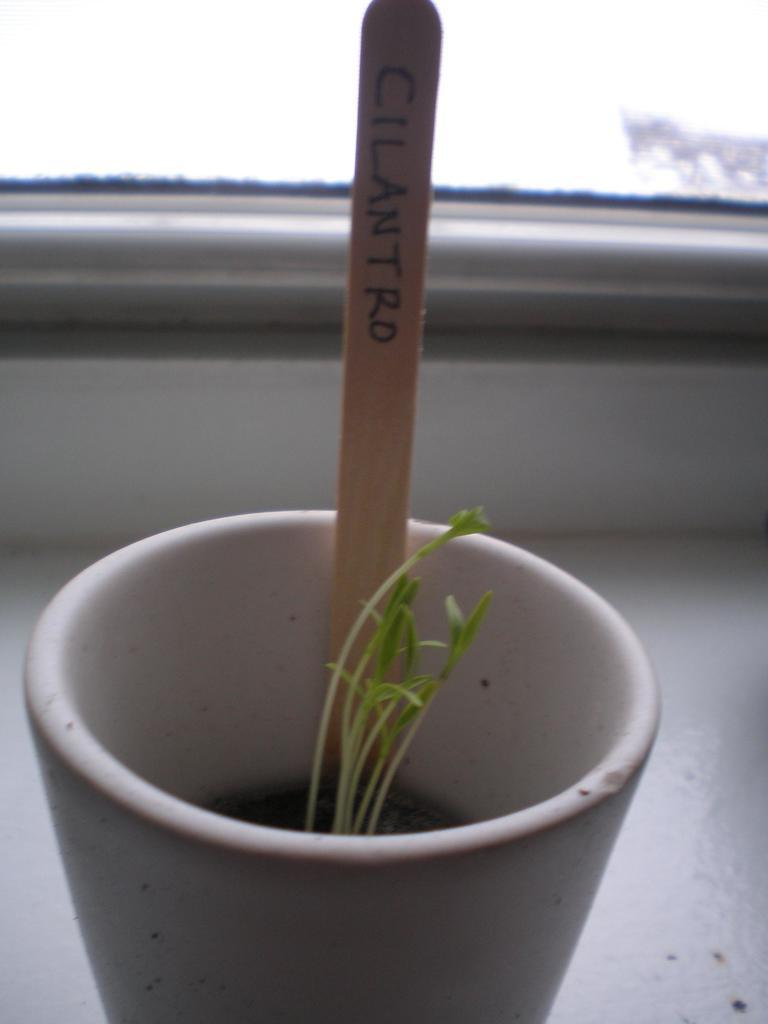What type of plants are in the cup at the bottom of the image? There are plants in a cup at the bottom of the image. What else can be seen in the image besides the plants in the cup? There is a stick in the image. What type of trip can be seen in the image? There is no trip visible in the image; it only contains plants in a cup and a stick. How does the rose feel about being in the image? There is no rose present in the image, so it is not possible to determine how it might feel. 